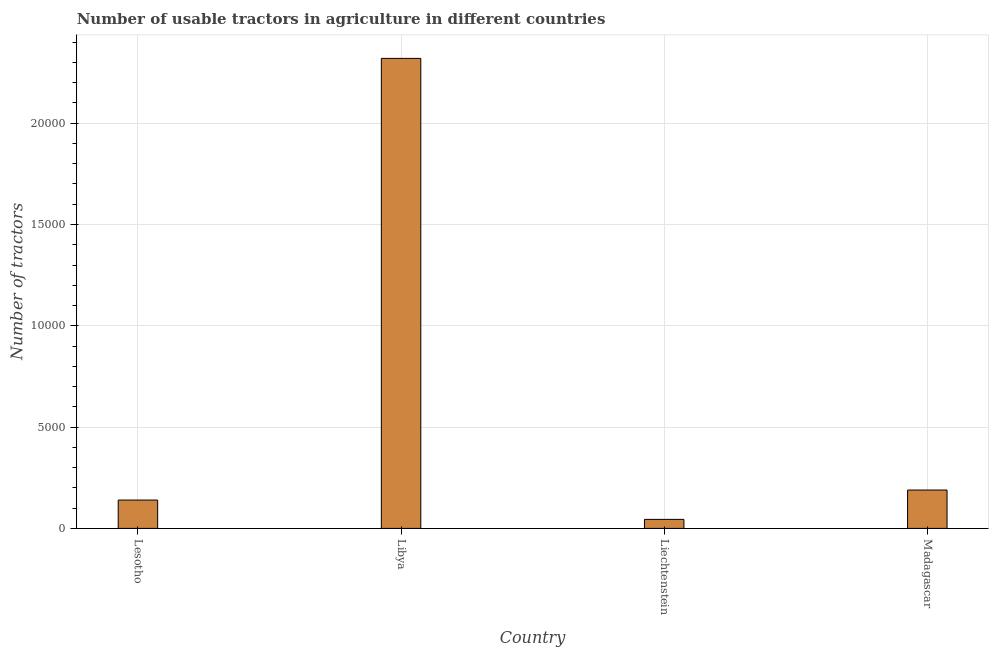Does the graph contain any zero values?
Give a very brief answer. No. What is the title of the graph?
Your answer should be compact. Number of usable tractors in agriculture in different countries. What is the label or title of the X-axis?
Provide a short and direct response. Country. What is the label or title of the Y-axis?
Provide a short and direct response. Number of tractors. What is the number of tractors in Madagascar?
Provide a succinct answer. 1894. Across all countries, what is the maximum number of tractors?
Give a very brief answer. 2.32e+04. Across all countries, what is the minimum number of tractors?
Your answer should be compact. 446. In which country was the number of tractors maximum?
Your answer should be very brief. Libya. In which country was the number of tractors minimum?
Your answer should be very brief. Liechtenstein. What is the sum of the number of tractors?
Keep it short and to the point. 2.69e+04. What is the difference between the number of tractors in Libya and Madagascar?
Offer a very short reply. 2.13e+04. What is the average number of tractors per country?
Keep it short and to the point. 6735. What is the median number of tractors?
Provide a succinct answer. 1647. What is the ratio of the number of tractors in Lesotho to that in Madagascar?
Make the answer very short. 0.74. Is the number of tractors in Lesotho less than that in Madagascar?
Offer a terse response. Yes. Is the difference between the number of tractors in Lesotho and Liechtenstein greater than the difference between any two countries?
Provide a short and direct response. No. What is the difference between the highest and the second highest number of tractors?
Provide a short and direct response. 2.13e+04. What is the difference between the highest and the lowest number of tractors?
Ensure brevity in your answer.  2.28e+04. How many bars are there?
Give a very brief answer. 4. Are all the bars in the graph horizontal?
Make the answer very short. No. What is the Number of tractors in Lesotho?
Keep it short and to the point. 1400. What is the Number of tractors in Libya?
Provide a short and direct response. 2.32e+04. What is the Number of tractors of Liechtenstein?
Ensure brevity in your answer.  446. What is the Number of tractors of Madagascar?
Offer a very short reply. 1894. What is the difference between the Number of tractors in Lesotho and Libya?
Make the answer very short. -2.18e+04. What is the difference between the Number of tractors in Lesotho and Liechtenstein?
Ensure brevity in your answer.  954. What is the difference between the Number of tractors in Lesotho and Madagascar?
Keep it short and to the point. -494. What is the difference between the Number of tractors in Libya and Liechtenstein?
Ensure brevity in your answer.  2.28e+04. What is the difference between the Number of tractors in Libya and Madagascar?
Provide a succinct answer. 2.13e+04. What is the difference between the Number of tractors in Liechtenstein and Madagascar?
Give a very brief answer. -1448. What is the ratio of the Number of tractors in Lesotho to that in Liechtenstein?
Provide a short and direct response. 3.14. What is the ratio of the Number of tractors in Lesotho to that in Madagascar?
Your answer should be very brief. 0.74. What is the ratio of the Number of tractors in Libya to that in Liechtenstein?
Your answer should be very brief. 52.02. What is the ratio of the Number of tractors in Libya to that in Madagascar?
Your answer should be very brief. 12.25. What is the ratio of the Number of tractors in Liechtenstein to that in Madagascar?
Make the answer very short. 0.23. 